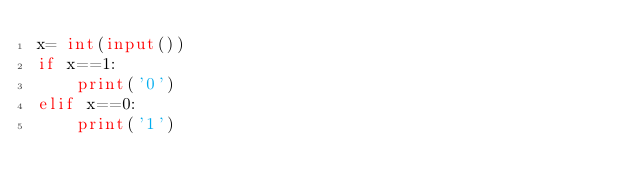<code> <loc_0><loc_0><loc_500><loc_500><_Python_>x= int(input())
if x==1:
    print('0')
elif x==0:
    print('1')</code> 